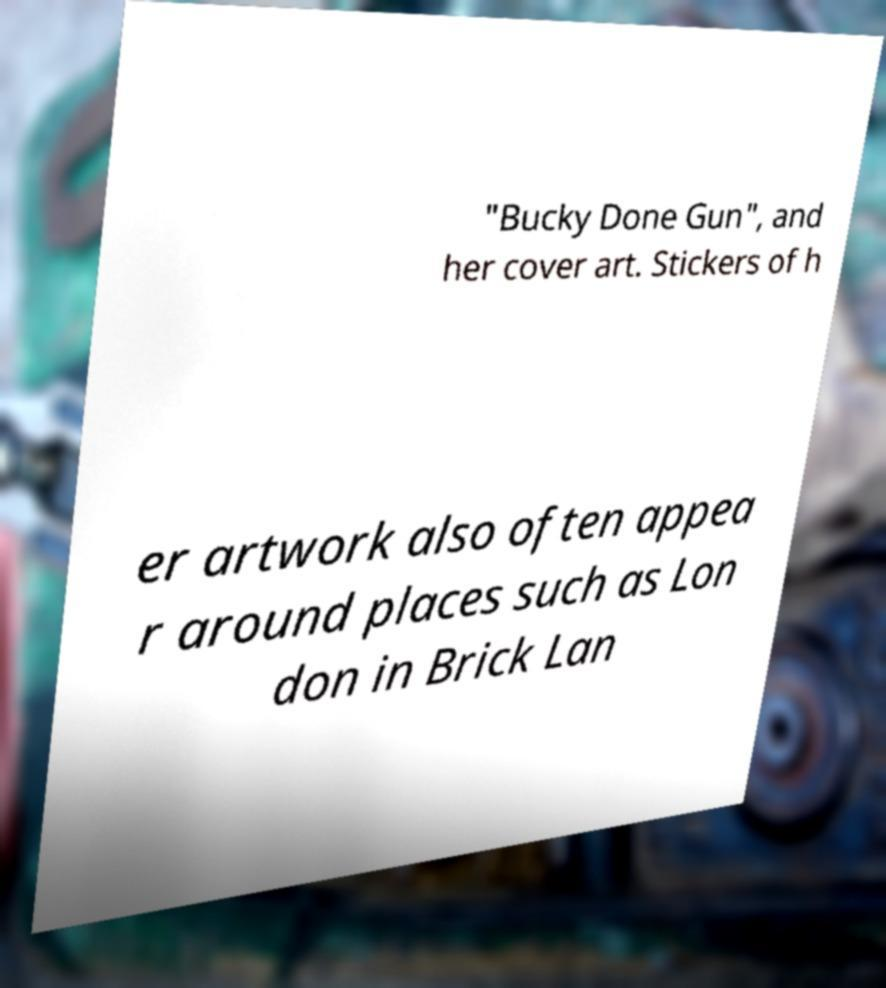What messages or text are displayed in this image? I need them in a readable, typed format. "Bucky Done Gun", and her cover art. Stickers of h er artwork also often appea r around places such as Lon don in Brick Lan 